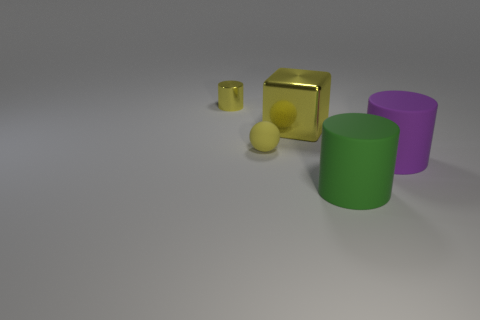What shape is the big shiny thing that is the same color as the small matte ball?
Keep it short and to the point. Cube. What is the size of the yellow rubber thing that is left of the rubber cylinder to the right of the green cylinder?
Provide a succinct answer. Small. There is a small yellow thing that is the same shape as the large green rubber object; what material is it?
Your answer should be very brief. Metal. How many shiny things are there?
Keep it short and to the point. 2. What is the color of the cylinder on the left side of the metallic object to the right of the cylinder that is on the left side of the green rubber object?
Offer a terse response. Yellow. Are there fewer green rubber things than tiny cyan balls?
Provide a short and direct response. No. The other matte thing that is the same shape as the big purple thing is what color?
Your answer should be compact. Green. There is another cylinder that is the same material as the big purple cylinder; what color is it?
Keep it short and to the point. Green. How many matte cylinders are the same size as the yellow metallic cylinder?
Offer a terse response. 0. What material is the purple cylinder?
Offer a terse response. Rubber. 